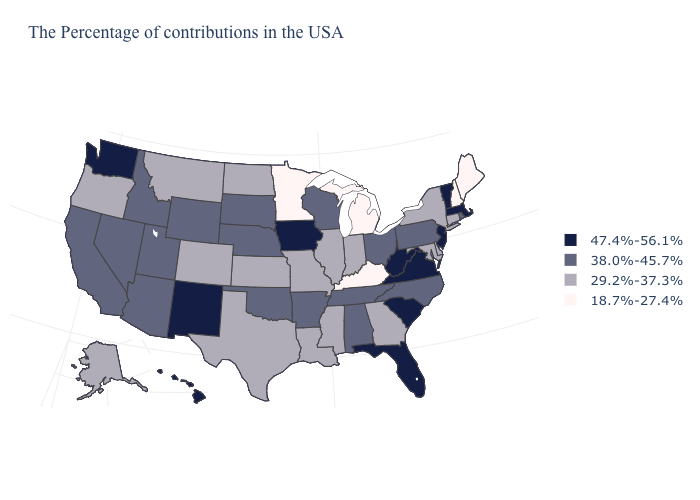Name the states that have a value in the range 18.7%-27.4%?
Write a very short answer. Maine, New Hampshire, Michigan, Kentucky, Minnesota. What is the value of Tennessee?
Quick response, please. 38.0%-45.7%. Is the legend a continuous bar?
Short answer required. No. Does New Hampshire have the lowest value in the Northeast?
Be succinct. Yes. What is the value of New Mexico?
Short answer required. 47.4%-56.1%. What is the value of Indiana?
Quick response, please. 29.2%-37.3%. Is the legend a continuous bar?
Be succinct. No. Is the legend a continuous bar?
Be succinct. No. Does the map have missing data?
Quick response, please. No. What is the lowest value in the South?
Answer briefly. 18.7%-27.4%. What is the value of Idaho?
Give a very brief answer. 38.0%-45.7%. What is the value of Washington?
Answer briefly. 47.4%-56.1%. Does the map have missing data?
Write a very short answer. No. Name the states that have a value in the range 29.2%-37.3%?
Answer briefly. Connecticut, New York, Delaware, Maryland, Georgia, Indiana, Illinois, Mississippi, Louisiana, Missouri, Kansas, Texas, North Dakota, Colorado, Montana, Oregon, Alaska. What is the value of South Dakota?
Keep it brief. 38.0%-45.7%. 